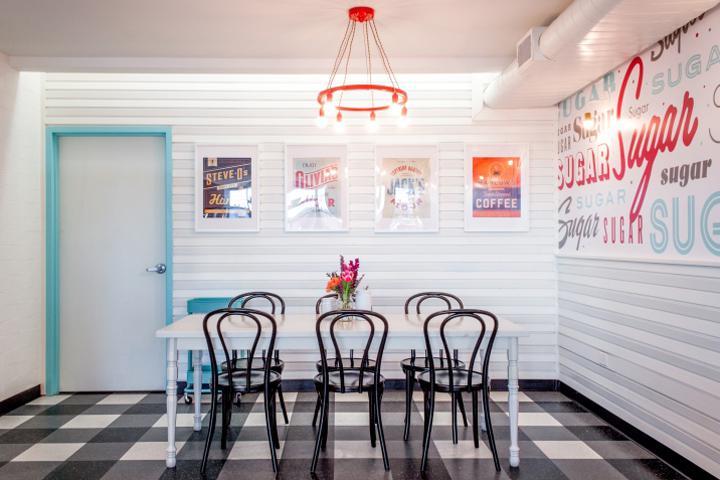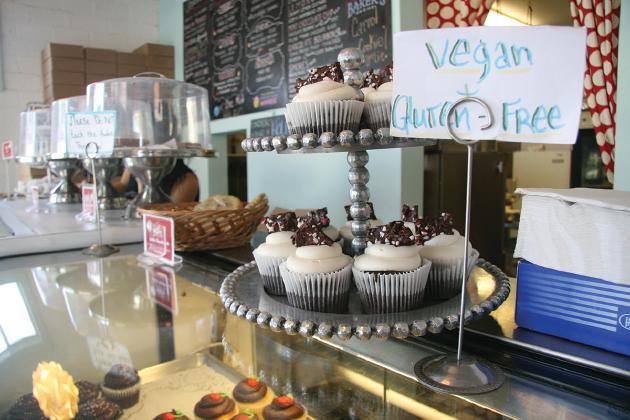The first image is the image on the left, the second image is the image on the right. Evaluate the accuracy of this statement regarding the images: "The left image is an interior featuring open-back black chairs around at least one white rectangular table on a black-and-white checkered floor.". Is it true? Answer yes or no. Yes. The first image is the image on the left, the second image is the image on the right. Evaluate the accuracy of this statement regarding the images: "In one image, a bakery has a seating area with black chairs and at least one white table.". Is it true? Answer yes or no. Yes. 